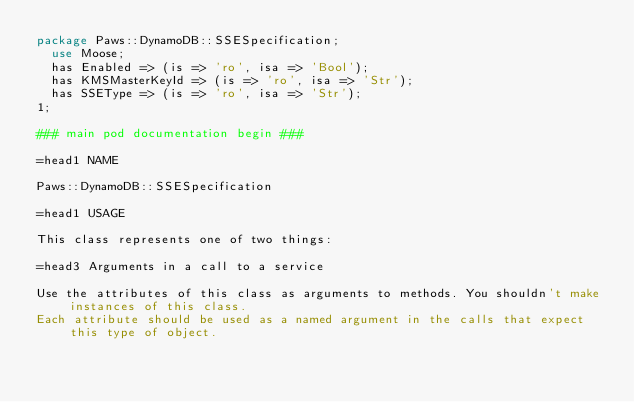Convert code to text. <code><loc_0><loc_0><loc_500><loc_500><_Perl_>package Paws::DynamoDB::SSESpecification;
  use Moose;
  has Enabled => (is => 'ro', isa => 'Bool');
  has KMSMasterKeyId => (is => 'ro', isa => 'Str');
  has SSEType => (is => 'ro', isa => 'Str');
1;

### main pod documentation begin ###

=head1 NAME

Paws::DynamoDB::SSESpecification

=head1 USAGE

This class represents one of two things:

=head3 Arguments in a call to a service

Use the attributes of this class as arguments to methods. You shouldn't make instances of this class. 
Each attribute should be used as a named argument in the calls that expect this type of object.
</code> 